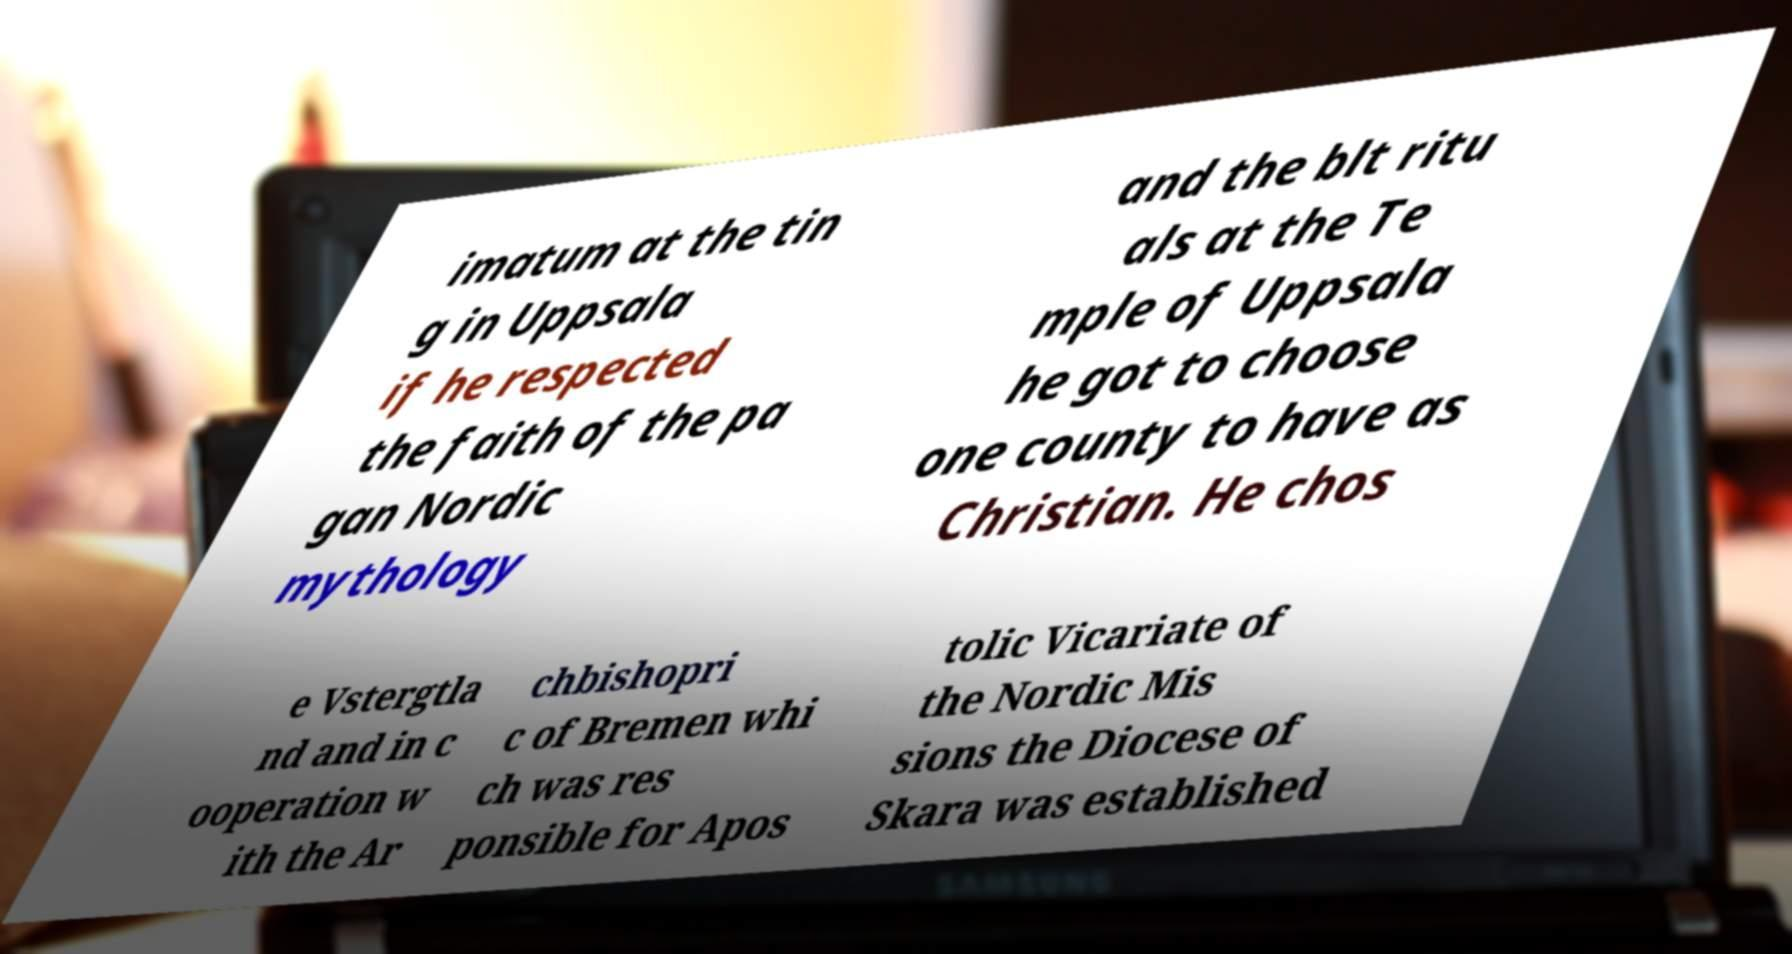There's text embedded in this image that I need extracted. Can you transcribe it verbatim? imatum at the tin g in Uppsala if he respected the faith of the pa gan Nordic mythology and the blt ritu als at the Te mple of Uppsala he got to choose one county to have as Christian. He chos e Vstergtla nd and in c ooperation w ith the Ar chbishopri c of Bremen whi ch was res ponsible for Apos tolic Vicariate of the Nordic Mis sions the Diocese of Skara was established 